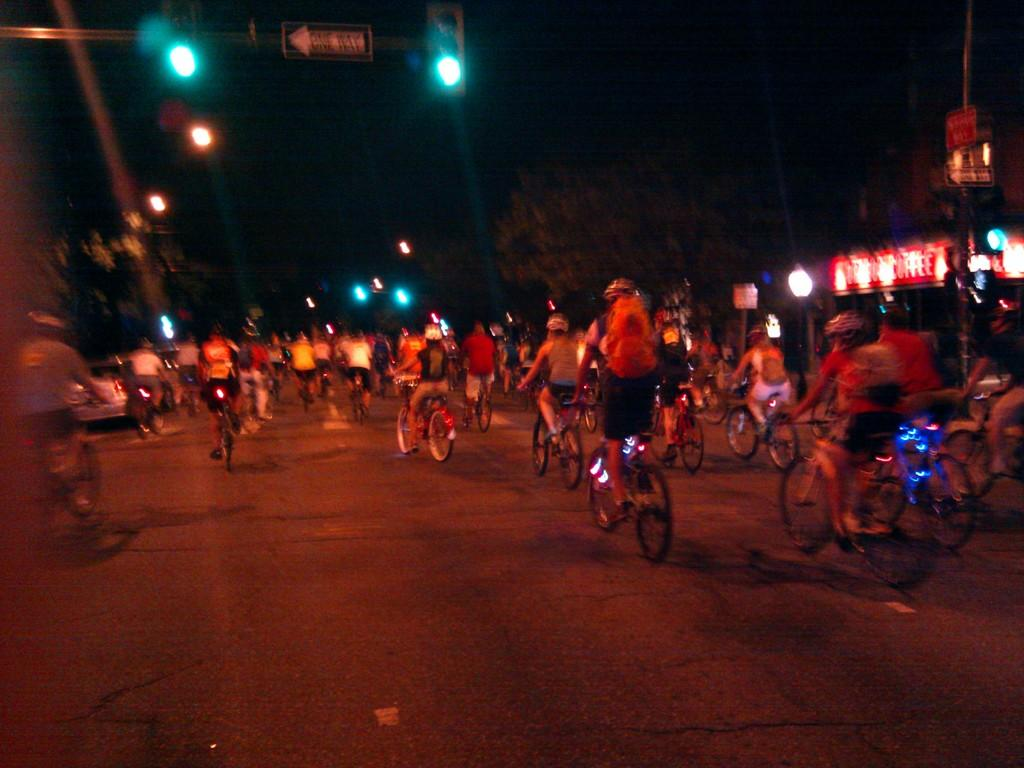What are the people in the image doing? The people in the image are riding bicycles. Where are the bicycles located? The bicycles are on a road. What can be seen in the background of the image? In the background of the image, there are lights, boards, trees, and poles. How would you describe the lighting conditions in the image? The background view is dark. Can you see any books or shelves in the image? No, there is no library or any indication of books or shelves in the image. Are there any ants visible on the road in the image? No, there are no ants present in the image. 